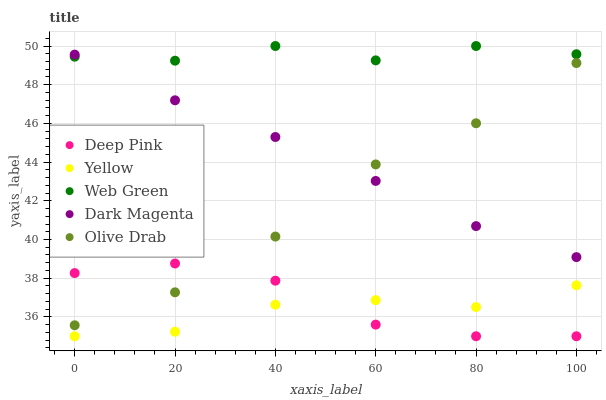Does Yellow have the minimum area under the curve?
Answer yes or no. Yes. Does Web Green have the maximum area under the curve?
Answer yes or no. Yes. Does Deep Pink have the minimum area under the curve?
Answer yes or no. No. Does Deep Pink have the maximum area under the curve?
Answer yes or no. No. Is Dark Magenta the smoothest?
Answer yes or no. Yes. Is Web Green the roughest?
Answer yes or no. Yes. Is Deep Pink the smoothest?
Answer yes or no. No. Is Deep Pink the roughest?
Answer yes or no. No. Does Deep Pink have the lowest value?
Answer yes or no. Yes. Does Web Green have the lowest value?
Answer yes or no. No. Does Web Green have the highest value?
Answer yes or no. Yes. Does Deep Pink have the highest value?
Answer yes or no. No. Is Yellow less than Olive Drab?
Answer yes or no. Yes. Is Web Green greater than Olive Drab?
Answer yes or no. Yes. Does Deep Pink intersect Yellow?
Answer yes or no. Yes. Is Deep Pink less than Yellow?
Answer yes or no. No. Is Deep Pink greater than Yellow?
Answer yes or no. No. Does Yellow intersect Olive Drab?
Answer yes or no. No. 